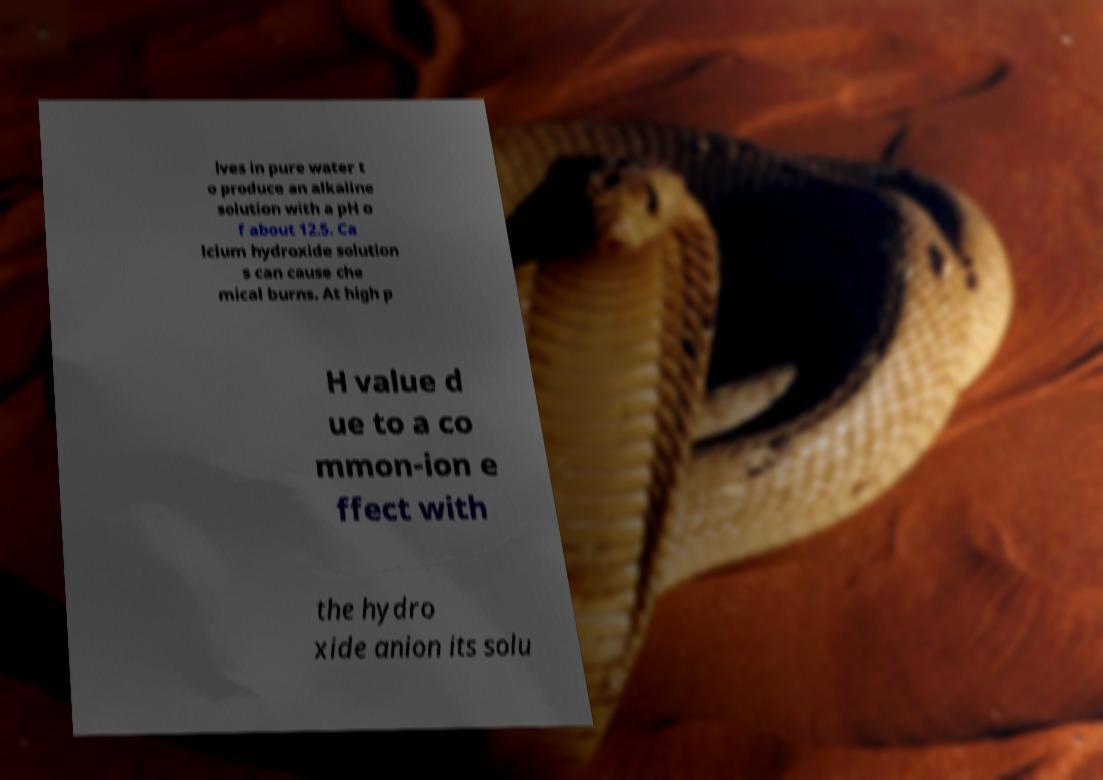Can you accurately transcribe the text from the provided image for me? lves in pure water t o produce an alkaline solution with a pH o f about 12.5. Ca lcium hydroxide solution s can cause che mical burns. At high p H value d ue to a co mmon-ion e ffect with the hydro xide anion its solu 